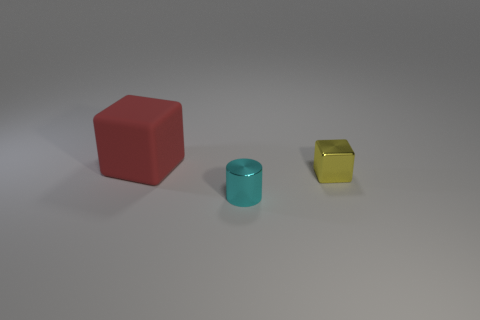Are there any other things that have the same size as the red rubber object?
Offer a terse response. No. Are there more tiny yellow metallic objects in front of the red cube than tiny blocks in front of the metallic cylinder?
Your answer should be compact. Yes. Is the material of the small object that is in front of the yellow cube the same as the cube that is on the right side of the large red object?
Provide a succinct answer. Yes. What shape is the yellow shiny object that is the same size as the cyan metallic object?
Your answer should be very brief. Cube. Are there any other big matte objects of the same shape as the big rubber thing?
Give a very brief answer. No. Are there any tiny cyan cylinders left of the tiny yellow cube?
Your answer should be compact. Yes. What material is the object that is behind the tiny cyan shiny thing and to the left of the yellow block?
Give a very brief answer. Rubber. Are the block on the right side of the red thing and the cyan cylinder made of the same material?
Keep it short and to the point. Yes. What is the small yellow block made of?
Ensure brevity in your answer.  Metal. There is a cube behind the tiny yellow metallic thing; what size is it?
Give a very brief answer. Large. 